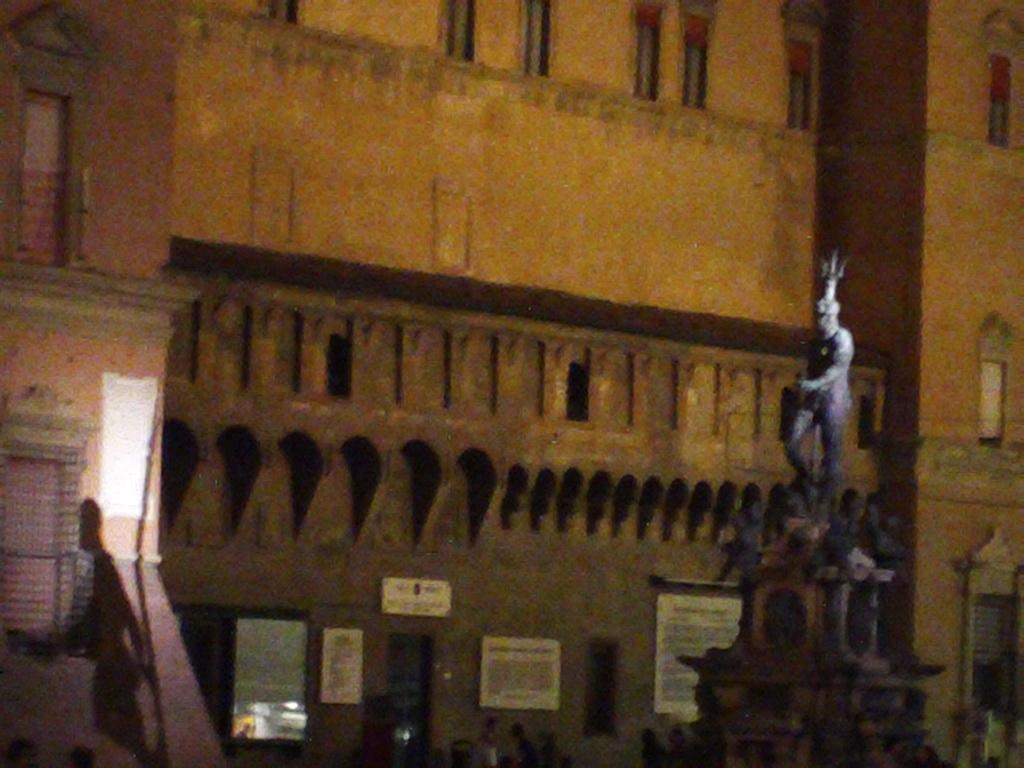What is the main subject in the image? There is a statue in the image. What can be seen in the background of the image? There are boards on a building and people visible in the background. Can you describe the shadow on the left side of the image? There is a person's shadow on the left side of the image. How many quinces are being smashed by the statue in the image? There are no quinces present in the image, and the statue is not shown smashing anything. 